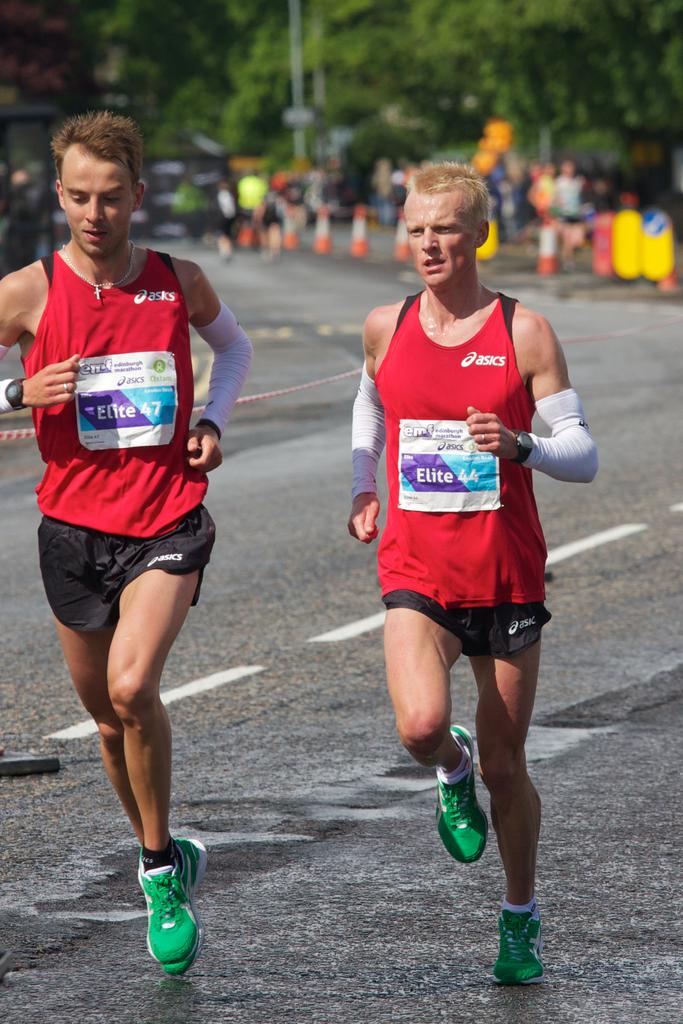Who made the red shirts?
Your answer should be compact. Asics. What is the short runner's number?
Provide a short and direct response. 44. 